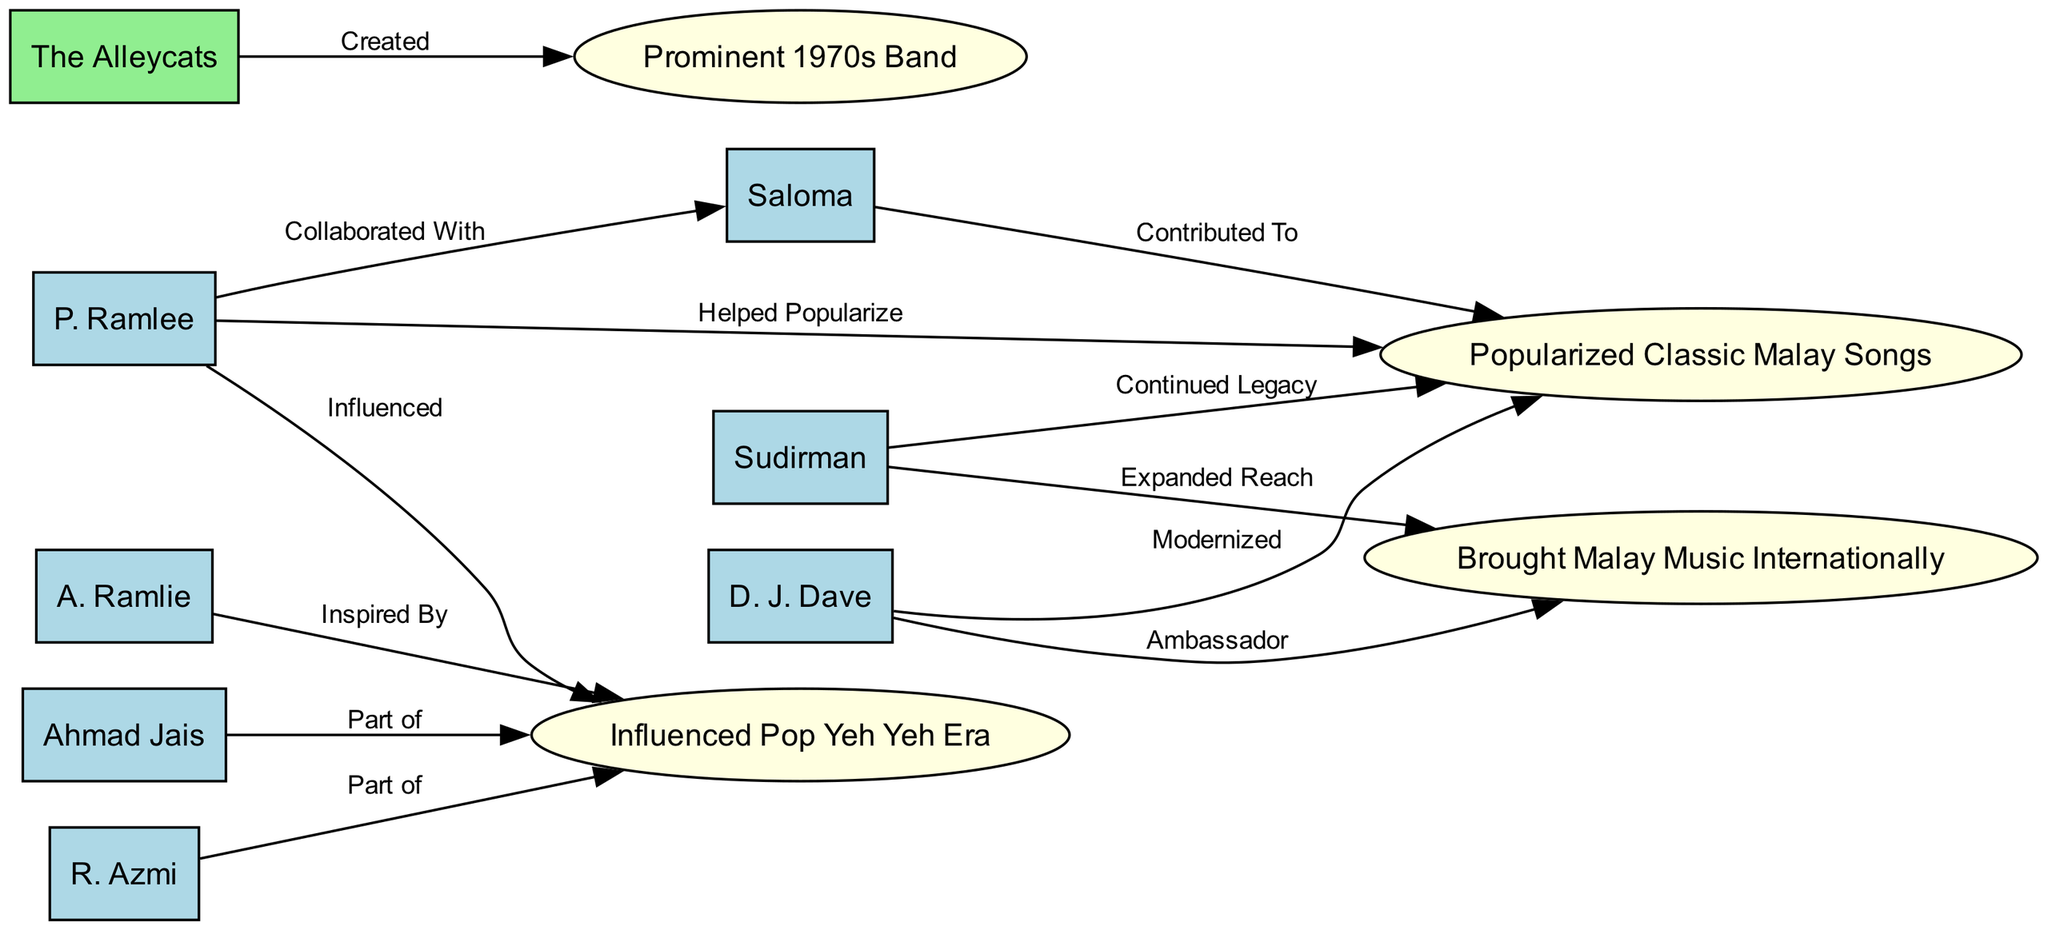What artist collaborated with Saloma? By examining the edges in the diagram, we find an edge connecting P. Ramlee to Saloma labeled "Collaborated With". Thus, P. Ramlee is the artist that collaborated with Saloma.
Answer: P. Ramlee How many artists are there in the diagram? Counting the nodes designated as "artist" in the diagram, we can identify 8 nodes labeled as artists (P. Ramlee, Saloma, Ahmad Jais, R. Azmi, A. Ramlie, Sudirman, D. J. Dave). Thus, there are 8 artists.
Answer: 8 What influence did Sudirman have with regard to classic Malay songs? The diagram shows an edge from Sudirman to "Continued Legacy" with a label which indicates that Sudirman continued the legacy of classic Malay songs, showcasing his role in preserving and promoting the genre.
Answer: Continued Legacy Which band is described as a prominent 1970s band? The edge in the diagram connects The Alleycats to the "Prominent 1970s Band" influence. Thus, The Alleycats is the band that fits this description.
Answer: The Alleycats Who is influenced by the Pop Yeh Yeh era? In the diagram, both Ahmad Jais and R. Azmi are indicated as being connected to the "Influenced Pop Yeh Yeh Era" influence, meaning they were part of this musical movement.
Answer: Ahmad Jais, R. Azmi What is the relationship between D. J. Dave and the influence of Malay music internationally? The diagram shows the edge linking D. J. Dave to "Brought Malay Music Internationally", indicating that he played a significant role in promoting Malay music on a global scale.
Answer: Brought Malay Music Internationally What did P. Ramlee help popularize in the music scene? An edge illustrates the connection from P. Ramlee to "Helped Popularize", referring specifically to classic Malay songs. This indicates his significant contribution to popularizing these songs during his career.
Answer: Helped Popularize Classic Malay Songs Which artist modernized classic Malay songs? The diagram connects D. J. Dave to the influence labeled "Modernized", which indicates that he played a key role in modernizing classic Malay songs.
Answer: D. J. Dave What artist expanded the reach of Malay music? The diagram reveals that Sudirman has an edge connecting him to "Expanded Reach", showing that he contributed to increasing the global presence and appreciation of Malay music.
Answer: Sudirman 